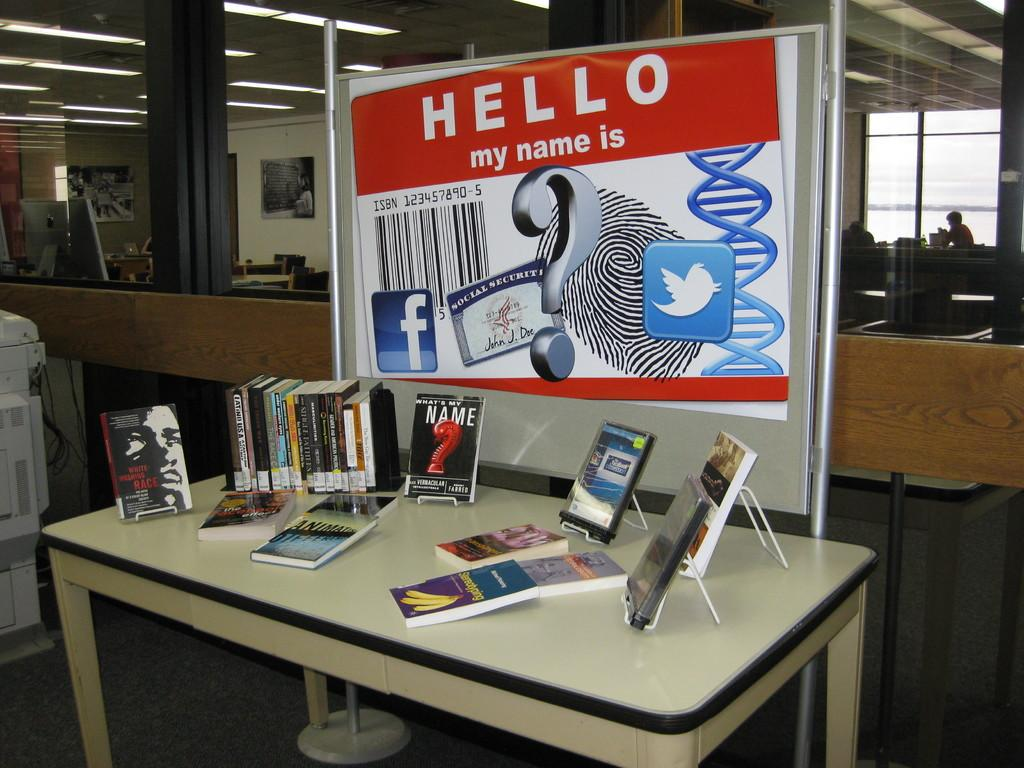<image>
Share a concise interpretation of the image provided. Display of books on a table and a sign that says "Hello my name is". 